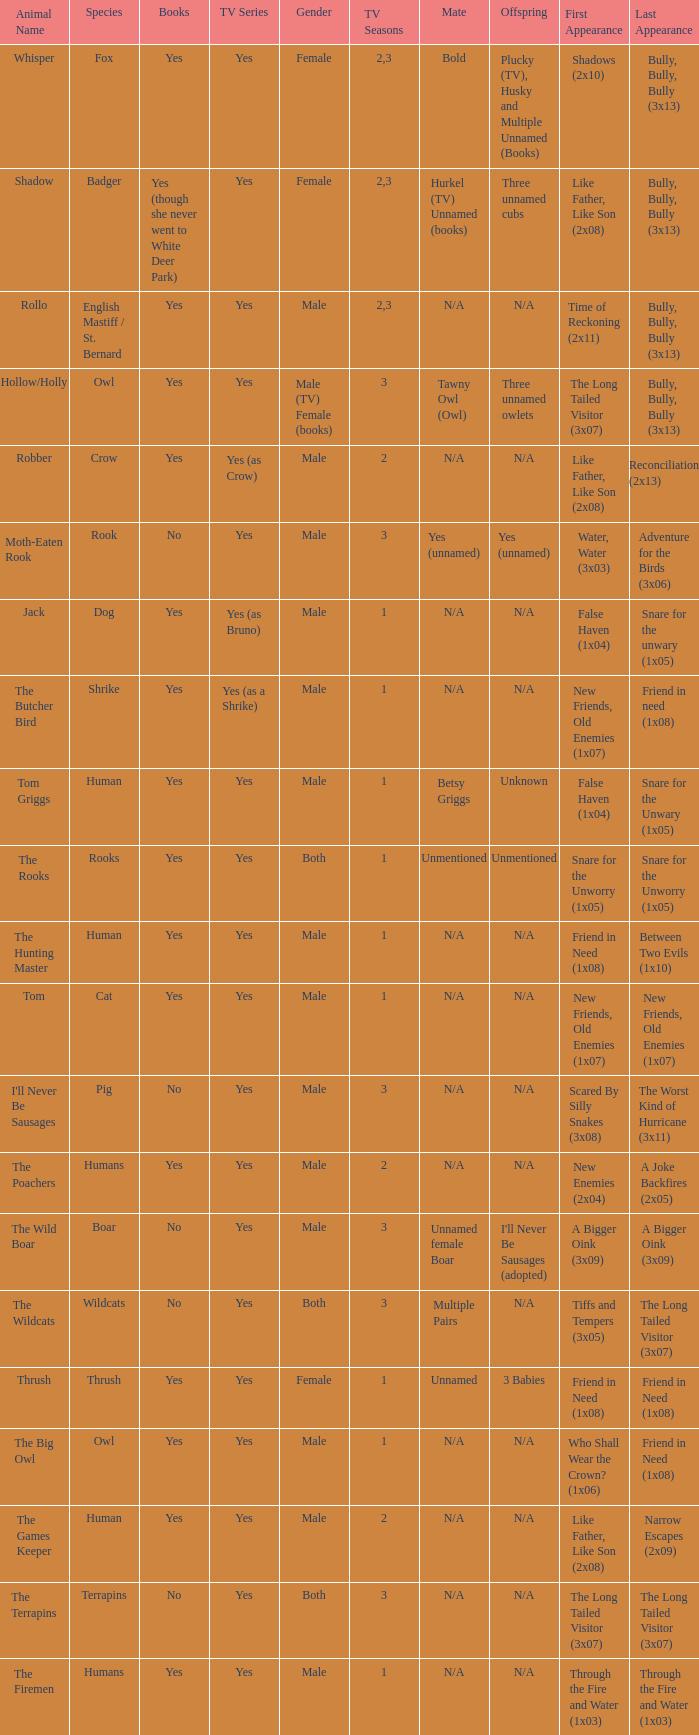Beyond season 1, who is the partner for hollow/holly in the episode titled "last appearance of bully, bully, bully (3x13)?" Tawny Owl (Owl). 